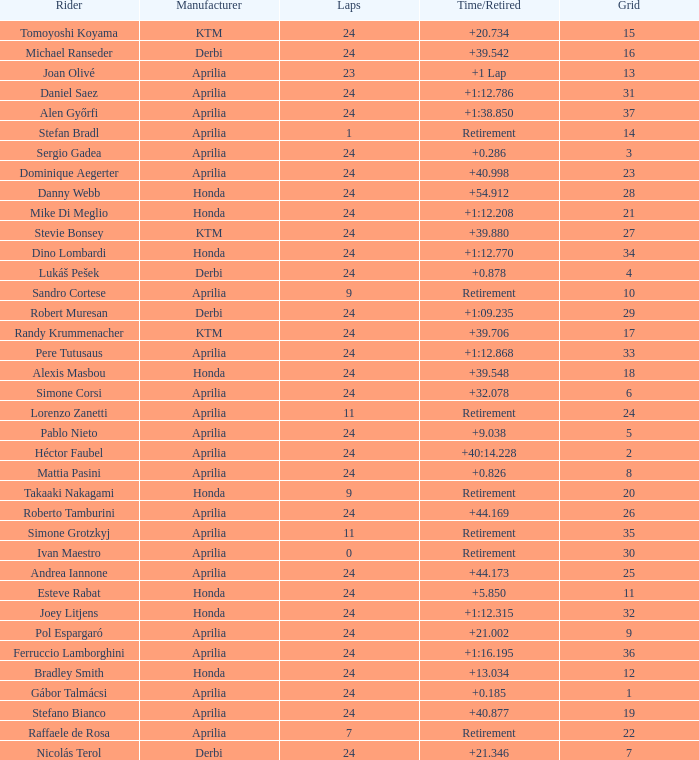What is the time with 10 grids? Retirement. 